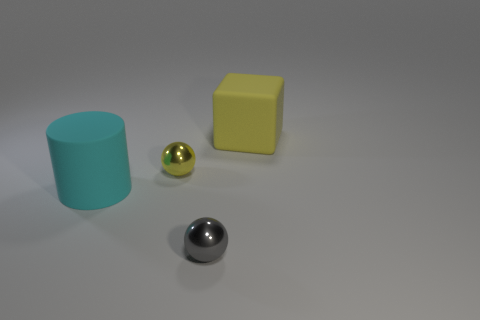Is the number of large cyan things to the right of the yellow shiny thing less than the number of cyan matte cylinders?
Offer a terse response. Yes. Is there any other thing that is the same shape as the gray thing?
Offer a terse response. Yes. What is the shape of the yellow object that is to the left of the yellow rubber object?
Your answer should be very brief. Sphere. The rubber object that is to the right of the big rubber object that is in front of the matte object that is on the right side of the cylinder is what shape?
Give a very brief answer. Cube. What number of objects are either purple matte spheres or shiny balls?
Keep it short and to the point. 2. There is a large cyan rubber thing that is in front of the rubber block; is it the same shape as the shiny object in front of the big cylinder?
Ensure brevity in your answer.  No. How many big things are on the right side of the yellow metal object and in front of the large yellow matte cube?
Your answer should be very brief. 0. What number of other things are there of the same size as the rubber cylinder?
Make the answer very short. 1. What is the material of the object that is on the left side of the gray metallic object and in front of the yellow metallic ball?
Make the answer very short. Rubber. Does the matte cylinder have the same color as the matte object to the right of the big cyan cylinder?
Offer a very short reply. No. 